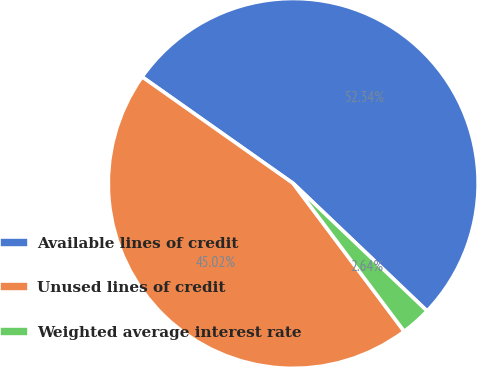Convert chart to OTSL. <chart><loc_0><loc_0><loc_500><loc_500><pie_chart><fcel>Available lines of credit<fcel>Unused lines of credit<fcel>Weighted average interest rate<nl><fcel>52.34%<fcel>45.02%<fcel>2.64%<nl></chart> 